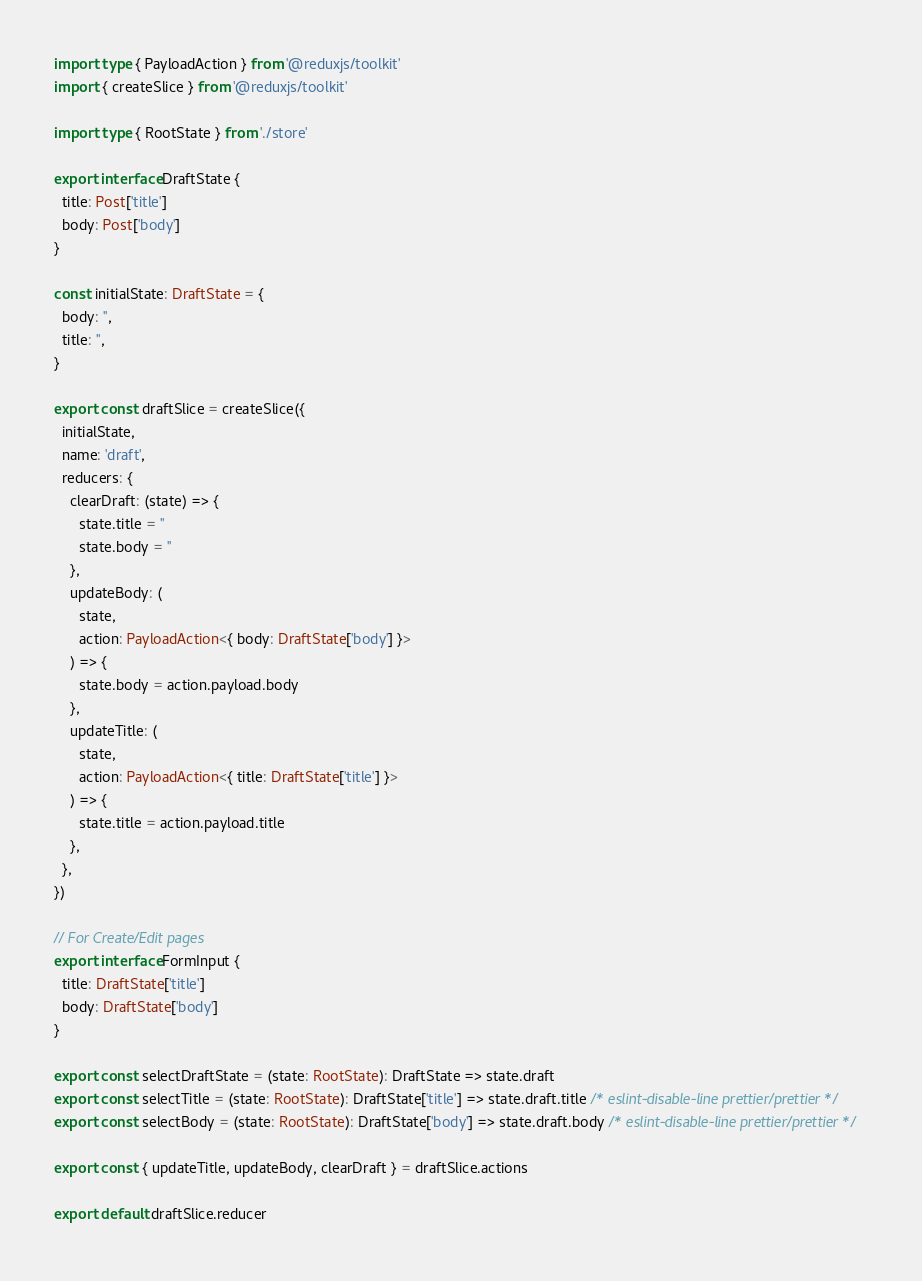Convert code to text. <code><loc_0><loc_0><loc_500><loc_500><_TypeScript_>import type { PayloadAction } from '@reduxjs/toolkit'
import { createSlice } from '@reduxjs/toolkit'

import type { RootState } from './store'

export interface DraftState {
  title: Post['title']
  body: Post['body']
}

const initialState: DraftState = {
  body: '',
  title: '',
}

export const draftSlice = createSlice({
  initialState,
  name: 'draft',
  reducers: {
    clearDraft: (state) => {
      state.title = ''
      state.body = ''
    },
    updateBody: (
      state,
      action: PayloadAction<{ body: DraftState['body'] }>
    ) => {
      state.body = action.payload.body
    },
    updateTitle: (
      state,
      action: PayloadAction<{ title: DraftState['title'] }>
    ) => {
      state.title = action.payload.title
    },
  },
})

// For Create/Edit pages
export interface FormInput {
  title: DraftState['title']
  body: DraftState['body']
}

export const selectDraftState = (state: RootState): DraftState => state.draft
export const selectTitle = (state: RootState): DraftState['title'] => state.draft.title /* eslint-disable-line prettier/prettier */
export const selectBody = (state: RootState): DraftState['body'] => state.draft.body /* eslint-disable-line prettier/prettier */

export const { updateTitle, updateBody, clearDraft } = draftSlice.actions

export default draftSlice.reducer
</code> 